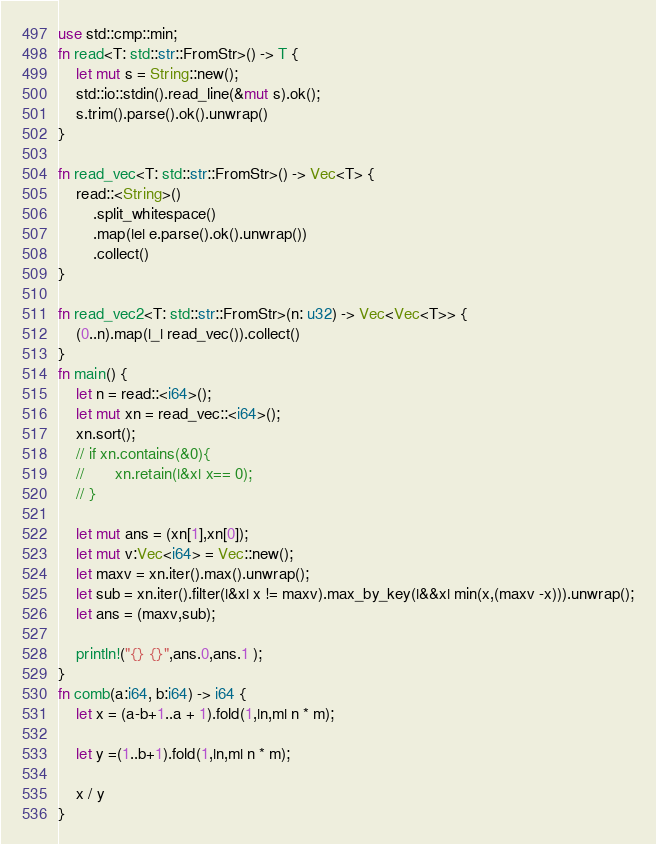<code> <loc_0><loc_0><loc_500><loc_500><_Rust_>use std::cmp::min;
fn read<T: std::str::FromStr>() -> T {
    let mut s = String::new();
    std::io::stdin().read_line(&mut s).ok();
    s.trim().parse().ok().unwrap()
}

fn read_vec<T: std::str::FromStr>() -> Vec<T> {
    read::<String>()
        .split_whitespace()
        .map(|e| e.parse().ok().unwrap())
        .collect()
}

fn read_vec2<T: std::str::FromStr>(n: u32) -> Vec<Vec<T>> {
    (0..n).map(|_| read_vec()).collect()
}
fn main() {
    let n = read::<i64>();
    let mut xn = read_vec::<i64>();
    xn.sort();
    // if xn.contains(&0){
    //       xn.retain(|&x| x== 0);
    // }
  
    let mut ans = (xn[1],xn[0]);
    let mut v:Vec<i64> = Vec::new();
    let maxv = xn.iter().max().unwrap();
    let sub = xn.iter().filter(|&x| x != maxv).max_by_key(|&&x| min(x,(maxv -x))).unwrap();
    let ans = (maxv,sub);

    println!("{} {}",ans.0,ans.1 );
}
fn comb(a:i64, b:i64) -> i64 {
    let x = (a-b+1..a + 1).fold(1,|n,m| n * m);
  
    let y =(1..b+1).fold(1,|n,m| n * m);
  
    x / y
}</code> 